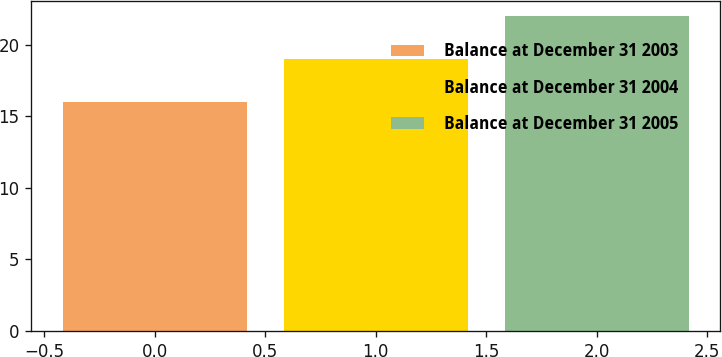Convert chart. <chart><loc_0><loc_0><loc_500><loc_500><bar_chart><fcel>Balance at December 31 2003<fcel>Balance at December 31 2004<fcel>Balance at December 31 2005<nl><fcel>16<fcel>19<fcel>22<nl></chart> 